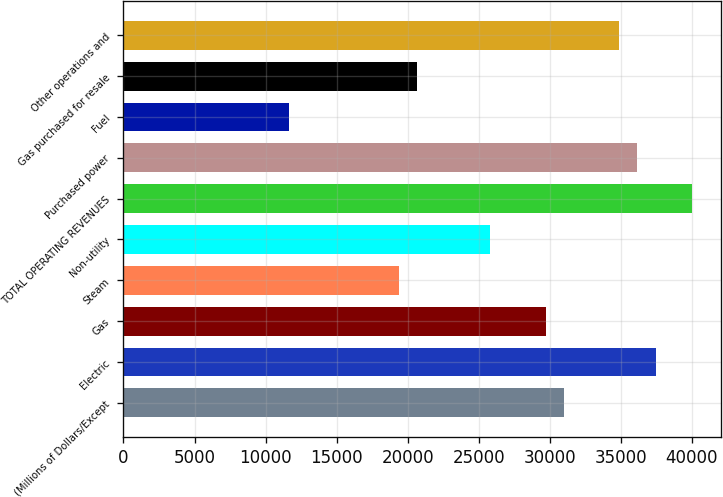Convert chart. <chart><loc_0><loc_0><loc_500><loc_500><bar_chart><fcel>(Millions of Dollars/Except<fcel>Electric<fcel>Gas<fcel>Steam<fcel>Non-utility<fcel>TOTAL OPERATING REVENUES<fcel>Purchased power<fcel>Fuel<fcel>Gas purchased for resale<fcel>Other operations and<nl><fcel>31004.2<fcel>37463.2<fcel>29712.4<fcel>19378<fcel>25837<fcel>40046.8<fcel>36171.4<fcel>11627.2<fcel>20669.8<fcel>34879.6<nl></chart> 